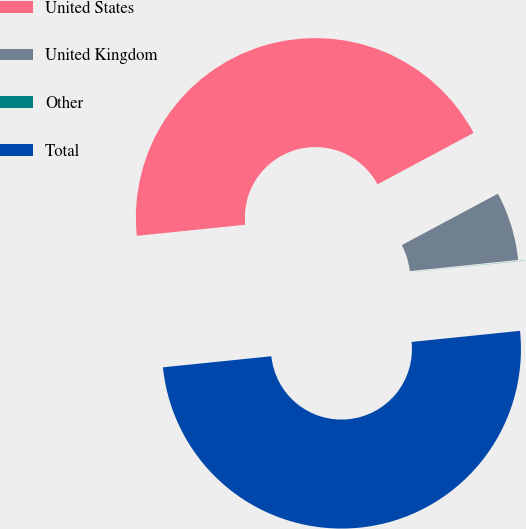<chart> <loc_0><loc_0><loc_500><loc_500><pie_chart><fcel>United States<fcel>United Kingdom<fcel>Other<fcel>Total<nl><fcel>43.8%<fcel>6.18%<fcel>0.02%<fcel>50.0%<nl></chart> 